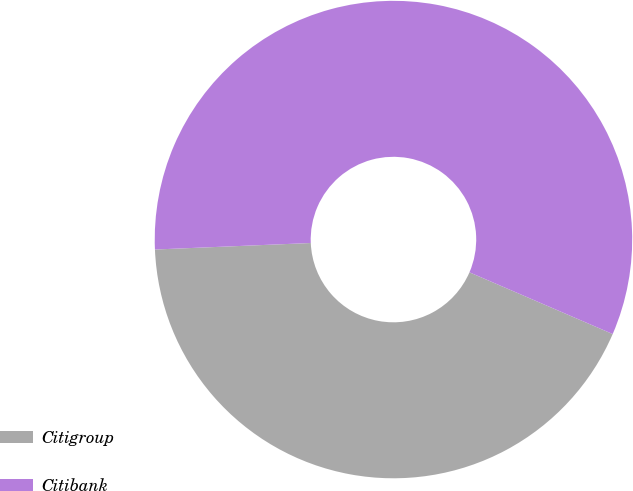<chart> <loc_0><loc_0><loc_500><loc_500><pie_chart><fcel>Citigroup<fcel>Citibank<nl><fcel>42.86%<fcel>57.14%<nl></chart> 